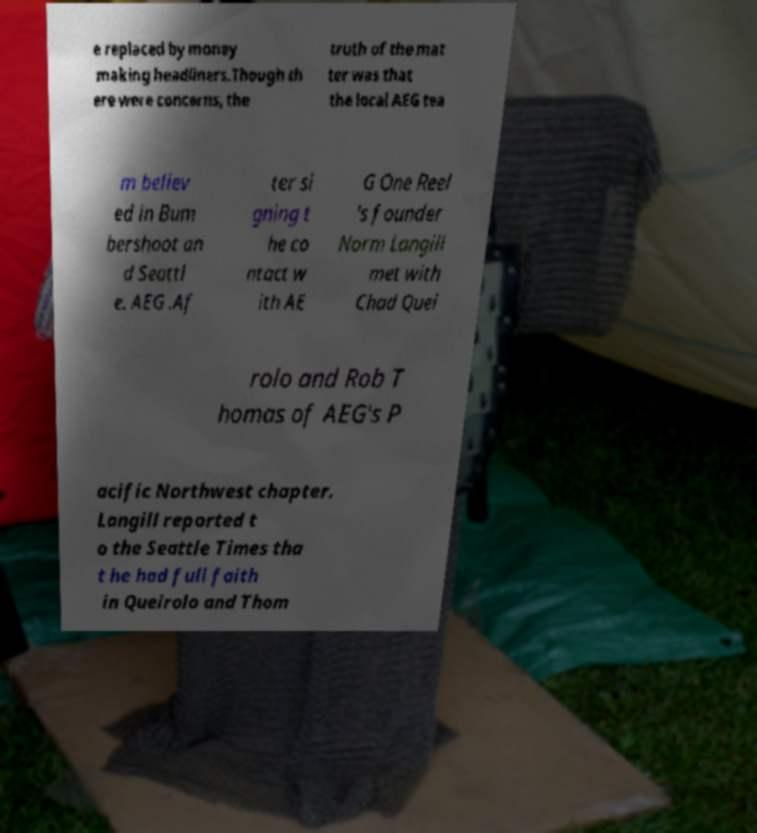For documentation purposes, I need the text within this image transcribed. Could you provide that? e replaced by money making headliners.Though th ere were concerns, the truth of the mat ter was that the local AEG tea m believ ed in Bum bershoot an d Seattl e. AEG .Af ter si gning t he co ntact w ith AE G One Reel 's founder Norm Langill met with Chad Quei rolo and Rob T homas of AEG's P acific Northwest chapter. Langill reported t o the Seattle Times tha t he had full faith in Queirolo and Thom 